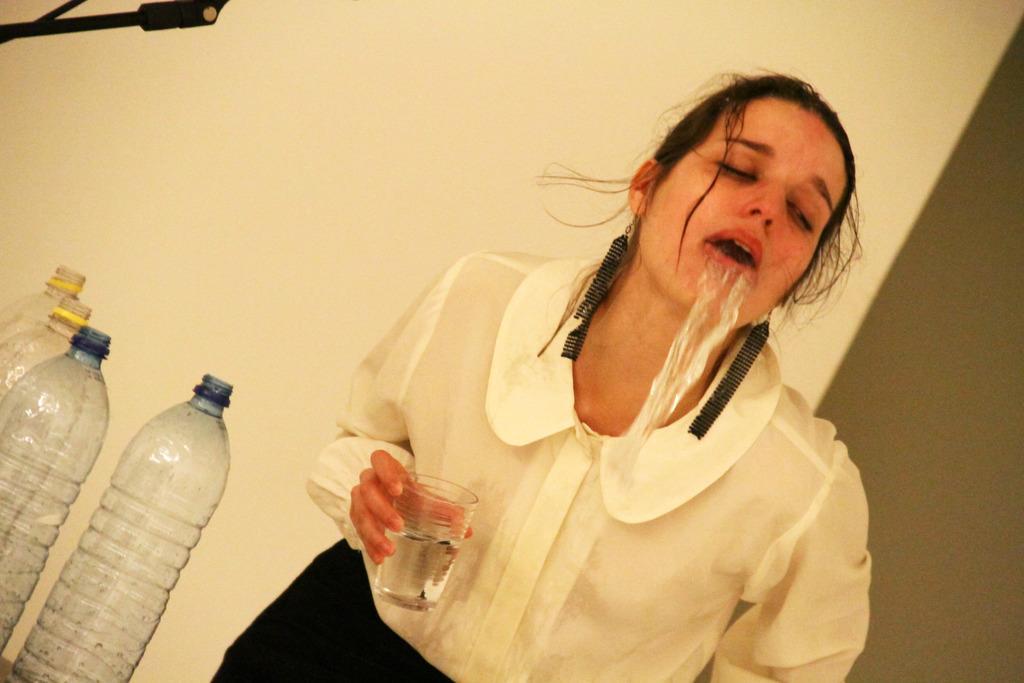How would you summarize this image in a sentence or two? This person standing and holding glass and throw up water and we can see bottles. Behind this person we can see wall. 